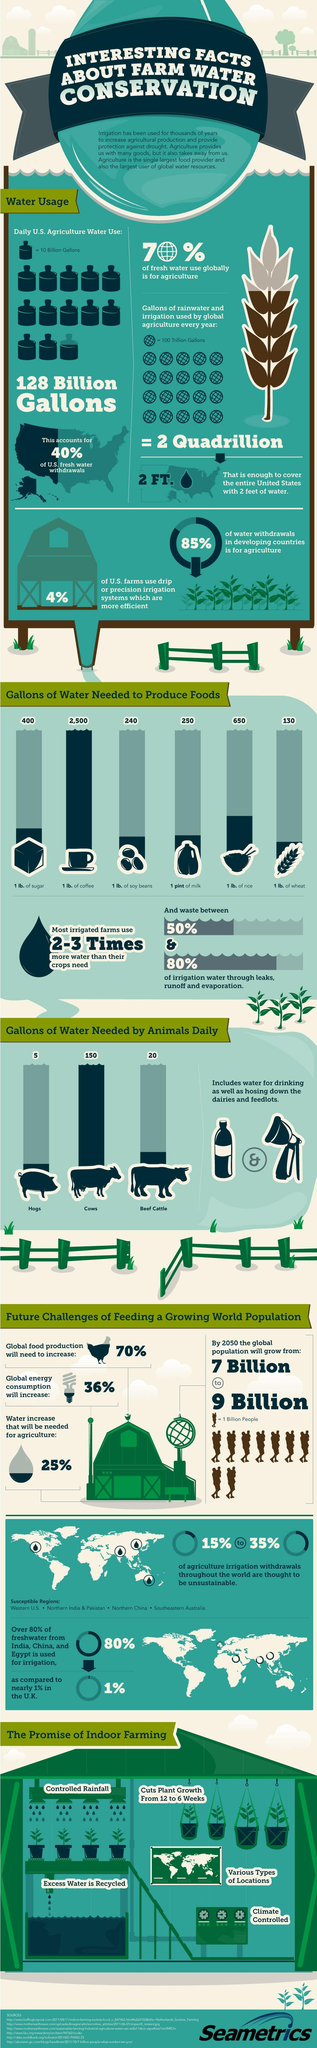Draw attention to some important aspects in this diagram. It is estimated that approximately 908.4 liters of water are required to grow 0.45 kilograms of soy beans. Cows, on average, require 130 gallons of water per day, while beef cattle require significantly less, on average, at 70 gallons per day. It is estimated that 250 gallons of water are required to produce 0.47 liters of milk. Wheat requires the least amount of water to be produced among all crops. It is estimated that approximately 2500 gallons of water are required to produce 0.45 kg of coffee. 